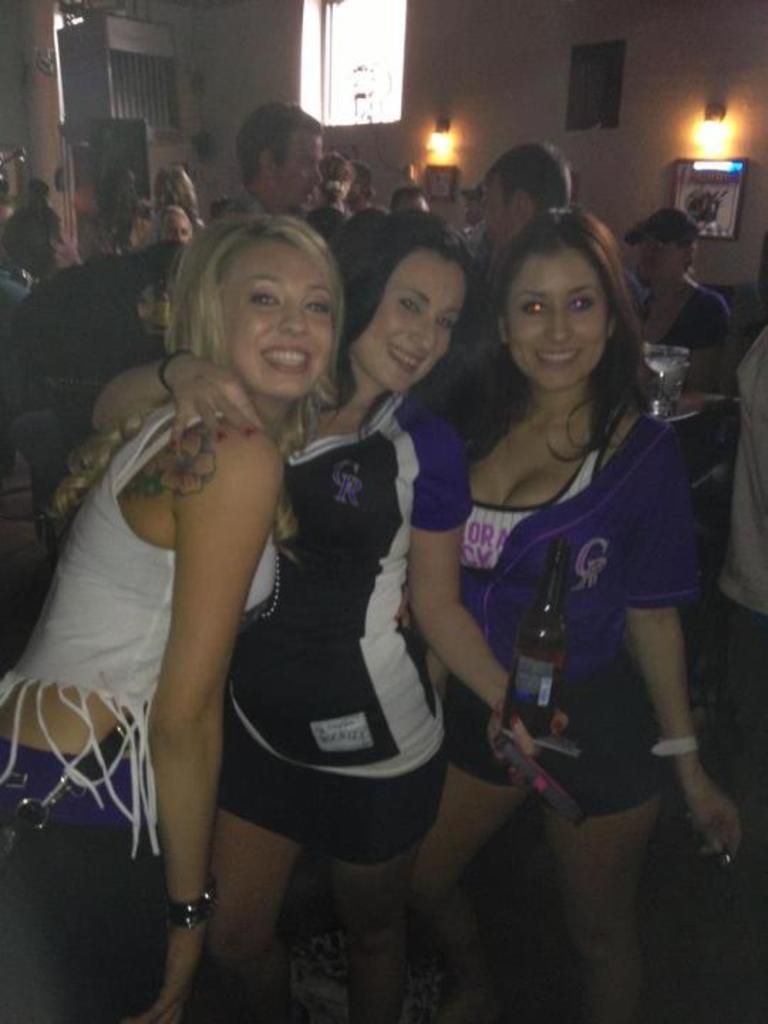Describe this image in one or two sentences. In the image there are three ladies standing and smiling. And holding the bottle in their hands. Behind them there are many people. In the background there is a wall with lights, frames, window and few other items. 